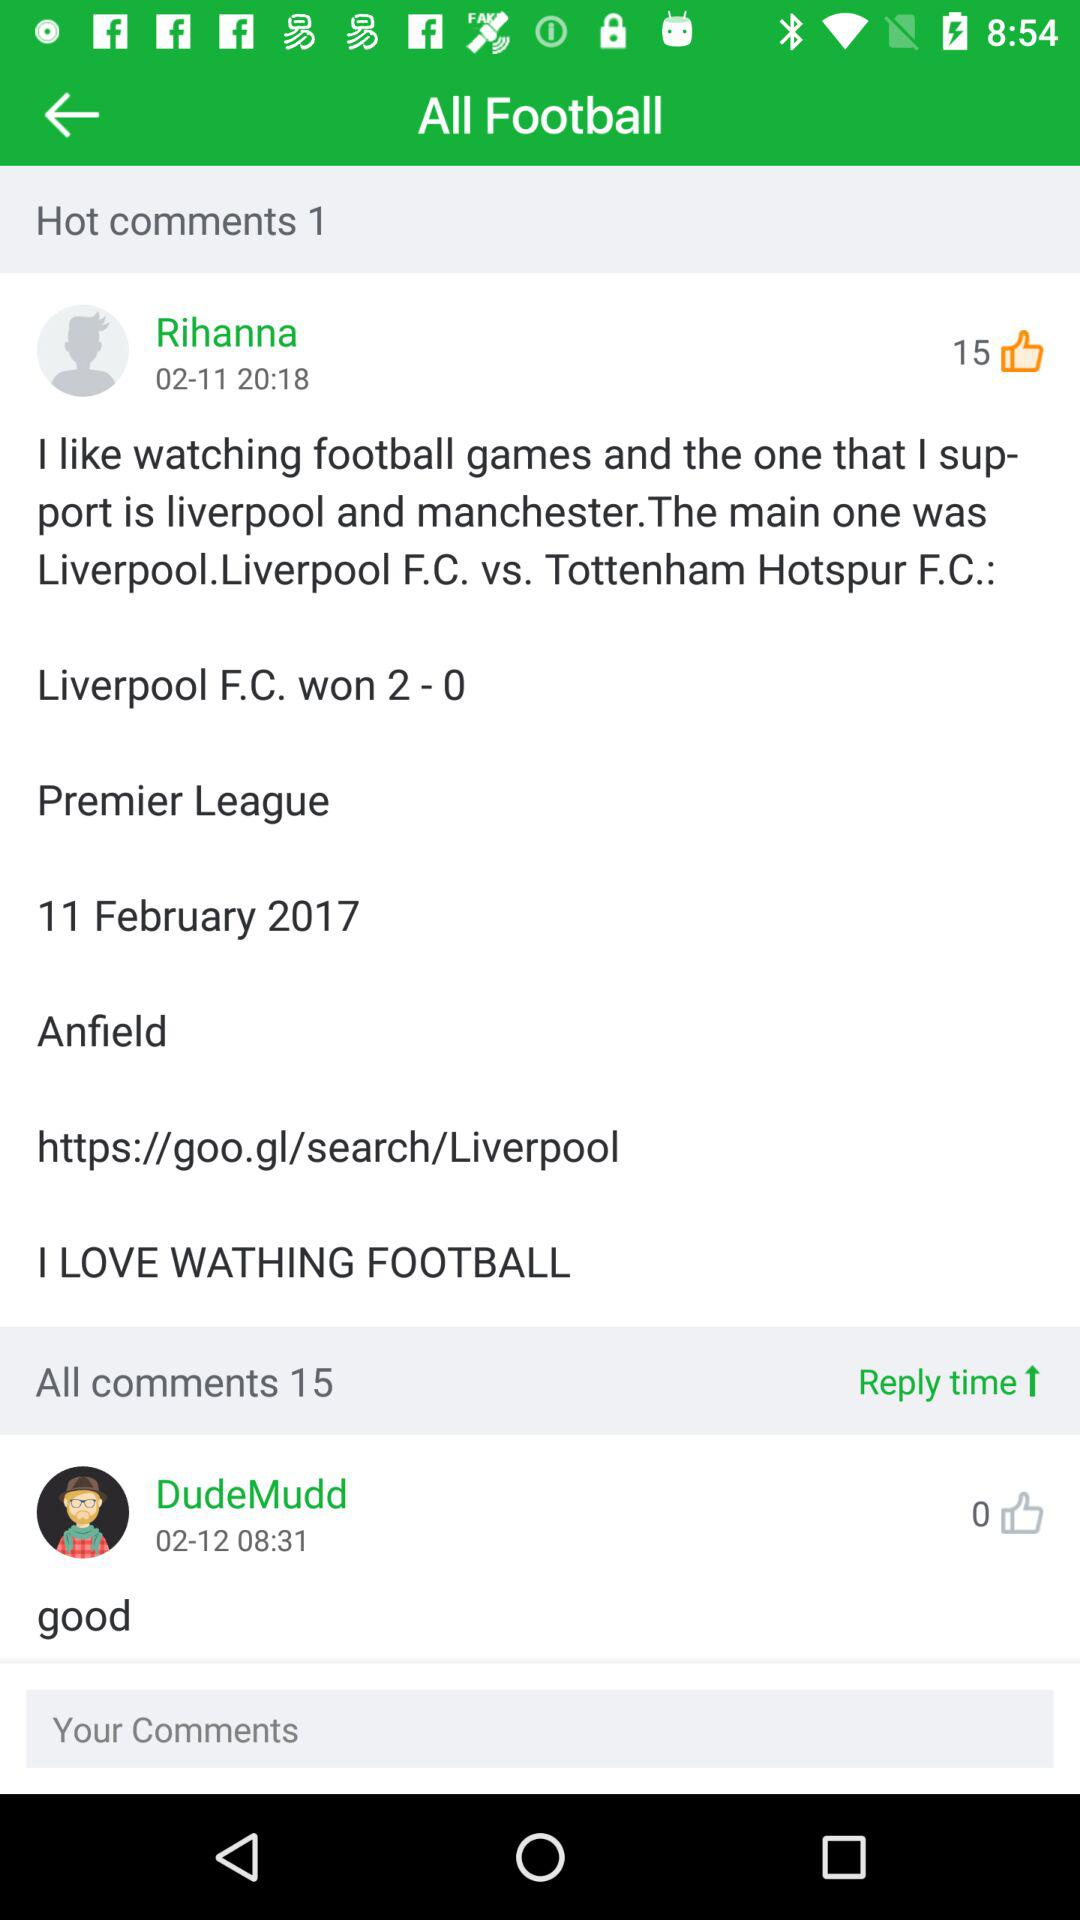What is the mentioned date for Rihanna's post? The mentioned date is November 2. 